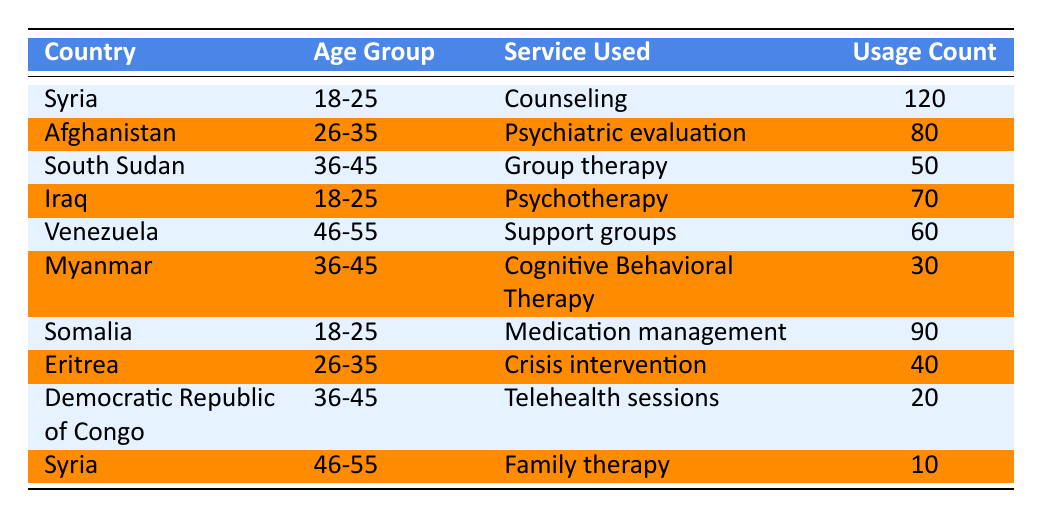What is the highest usage count for mental health services among refugees and asylum seekers? The highest usage count in the table is 120, corresponding to the service "Counseling" used by individuals from Syria aged 18-25.
Answer: 120 Which age group used the most diverse range of services? To determine the age group with the most diverse services, we can count the unique services per age group: 18-25 has 3 (Counseling, Psychotherapy, Medication management), 26-35 has 2 (Psychiatric evaluation, Crisis intervention), 36-45 has 3 (Group therapy, Cognitive Behavioral Therapy, Telehealth sessions), and 46-55 has 2 (Support groups, Family therapy). The age groups 18-25 and 36-45 have the most diverse range of services, each with 3 different services.
Answer: 18-25 and 36-45 Is there any service used by refugees and asylum seekers aged 46-55? Yes, there are two services used: "Support groups" has a usage count of 60, and "Family therapy" has a usage count of 10. This confirms that some services are utilized by individuals aged 46-55.
Answer: Yes What is the total usage count for mental health services provided to the age group 36-45? By adding the usage counts for the age group 36-45, we have Group therapy (50), Cognitive Behavioral Therapy (30), and Telehealth sessions (20). Therefore, the total is 50 + 30 + 20 = 100.
Answer: 100 For the country with the least usage count, what service was provided and what was the count? The row with the least usage count shows "Family therapy" used by refugees from Syria in the age group 46-55 with a usage count of 10.
Answer: Family therapy, 10 How many refugees from Somalia utilized mental health services, and which service was most popular? Somalia has 90 usage counts for "Medication management," making it the single most utilized service for this country. Adding all services from Somalia shows it had a total of 90 for this specific service.
Answer: 90, Medication management Which age group had the highest usage count among all data entries? Age group 18-25 had the highest total count of 210 (Counseling from Syria with 120 and Medication management from Somalia with 90), compared to other age groups.
Answer: 18-25 Is the service "Psychiatric evaluation" used by refugees from Somalia? No, the service "Psychiatric evaluation" is only listed under Afghanistan and is not utilized by any individuals from Somalia.
Answer: No 